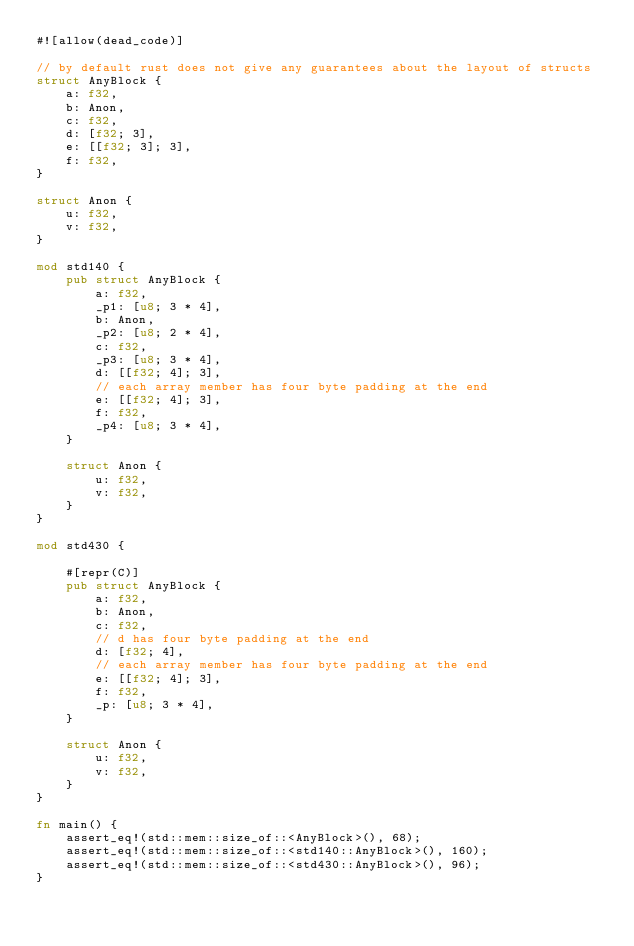<code> <loc_0><loc_0><loc_500><loc_500><_Rust_>#![allow(dead_code)]

// by default rust does not give any guarantees about the layout of structs
struct AnyBlock {
    a: f32,
    b: Anon,
    c: f32,
    d: [f32; 3],
    e: [[f32; 3]; 3],
    f: f32,
}

struct Anon {
    u: f32,
    v: f32,
}

mod std140 {
    pub struct AnyBlock {
        a: f32,
        _p1: [u8; 3 * 4],
        b: Anon,
        _p2: [u8; 2 * 4],
        c: f32,
        _p3: [u8; 3 * 4],
        d: [[f32; 4]; 3],
        // each array member has four byte padding at the end
        e: [[f32; 4]; 3],
        f: f32,
        _p4: [u8; 3 * 4],
    }

    struct Anon {
        u: f32,
        v: f32,
    }
}

mod std430 {

    #[repr(C)]
    pub struct AnyBlock {
        a: f32,
        b: Anon,
        c: f32,
        // d has four byte padding at the end
        d: [f32; 4],
        // each array member has four byte padding at the end
        e: [[f32; 4]; 3],
        f: f32,
        _p: [u8; 3 * 4],
    }

    struct Anon {
        u: f32,
        v: f32,
    }
}

fn main() {
    assert_eq!(std::mem::size_of::<AnyBlock>(), 68);
    assert_eq!(std::mem::size_of::<std140::AnyBlock>(), 160);
    assert_eq!(std::mem::size_of::<std430::AnyBlock>(), 96);
}
</code> 